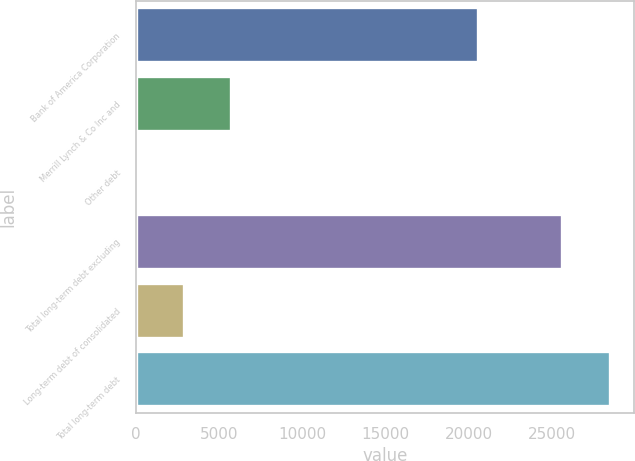Convert chart. <chart><loc_0><loc_0><loc_500><loc_500><bar_chart><fcel>Bank of America Corporation<fcel>Merrill Lynch & Co Inc and<fcel>Other debt<fcel>Total long-term debt excluding<fcel>Long-term debt of consolidated<fcel>Total long-term debt<nl><fcel>20575<fcel>5748.4<fcel>15<fcel>25621<fcel>2898<fcel>28519<nl></chart> 